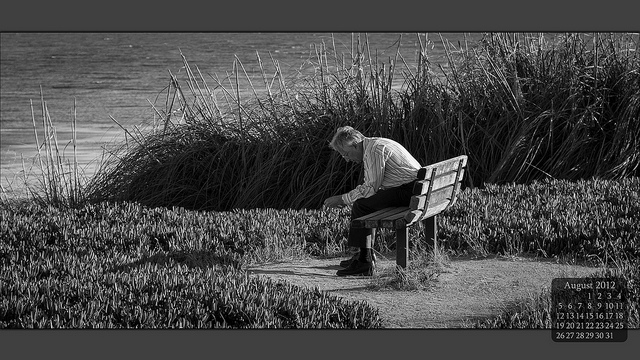Please transcribe the text information in this image. August 2012 4 3 2 26 27 28 29 30 31 19 20 21 22 23 24 25 18 17 16 15 14 13 12 11 10 9 8 7 6 5 1 